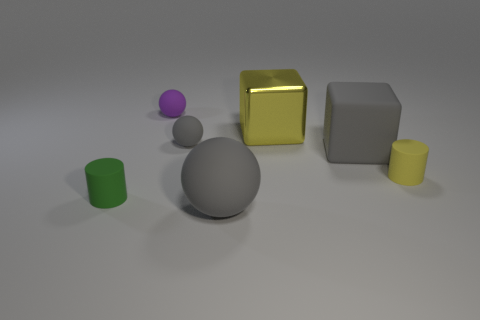What could be the purpose of these objects together like this? These objects might be used for a variety of purposes. It could be a simple display meant for educational use, such as for teaching geometry and showcasing different shapes. Alternatively, it could be part of a visual art project or a set-up for testing photographic lighting and reflections since objects with various shapes and textures interact with light differently. 